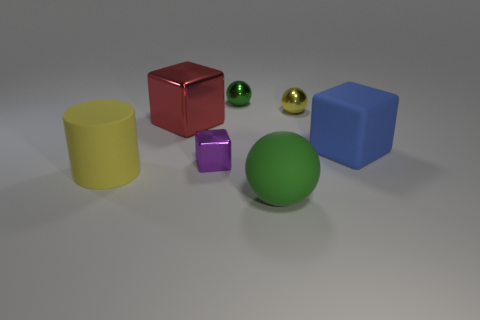The large metal object that is the same shape as the tiny purple thing is what color?
Make the answer very short. Red. Do the rubber thing behind the purple metallic thing and the purple shiny thing have the same size?
Your answer should be very brief. No. The shiny object that is the same color as the large rubber sphere is what shape?
Your answer should be compact. Sphere. How many objects have the same material as the large green ball?
Offer a terse response. 2. What material is the green object that is on the right side of the small metallic ball on the left side of the ball in front of the blue thing made of?
Offer a terse response. Rubber. The rubber thing that is to the right of the green ball that is to the right of the small green thing is what color?
Provide a succinct answer. Blue. What is the color of the metal block that is the same size as the yellow sphere?
Your response must be concise. Purple. What number of big objects are either blue cylinders or red cubes?
Provide a short and direct response. 1. Is the number of large blue objects that are to the right of the big green ball greater than the number of small yellow spheres that are on the left side of the yellow sphere?
Your answer should be very brief. Yes. How many other things are there of the same size as the green metal sphere?
Offer a very short reply. 2. 